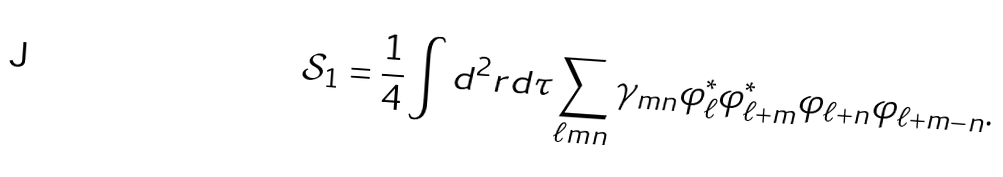Convert formula to latex. <formula><loc_0><loc_0><loc_500><loc_500>\mathcal { S } _ { 1 } = \frac { 1 } { 4 } \int d ^ { 2 } r d \tau \sum _ { \ell m n } \gamma _ { m n } \varphi _ { \ell } ^ { \ast } \varphi _ { \ell + m } ^ { \ast } \varphi _ { \ell + n } \varphi _ { \ell + m - n } .</formula> 